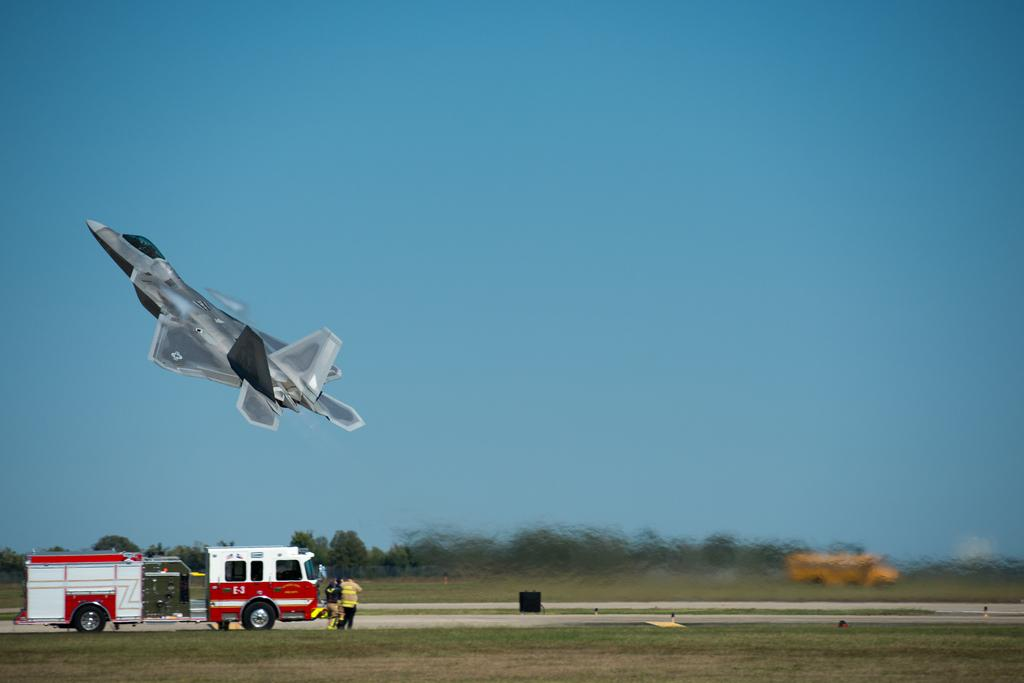How many people are in the image? There are two persons in front of the vehicle. What is located on the left side of the image? There is a jet on the left side of the image. What can be seen in the background of the image? There is a sky visible in the background of the image. What type of plastic is used to twist the jet's wings in the image? There is no plastic or twisting of wings present in the image; the jet is depicted as a solid object. 